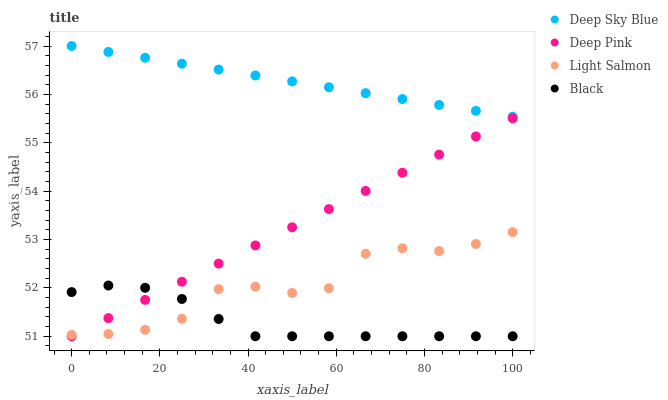Does Black have the minimum area under the curve?
Answer yes or no. Yes. Does Deep Sky Blue have the maximum area under the curve?
Answer yes or no. Yes. Does Deep Pink have the minimum area under the curve?
Answer yes or no. No. Does Deep Pink have the maximum area under the curve?
Answer yes or no. No. Is Deep Sky Blue the smoothest?
Answer yes or no. Yes. Is Light Salmon the roughest?
Answer yes or no. Yes. Is Deep Pink the smoothest?
Answer yes or no. No. Is Deep Pink the roughest?
Answer yes or no. No. Does Deep Pink have the lowest value?
Answer yes or no. Yes. Does Deep Sky Blue have the lowest value?
Answer yes or no. No. Does Deep Sky Blue have the highest value?
Answer yes or no. Yes. Does Deep Pink have the highest value?
Answer yes or no. No. Is Light Salmon less than Deep Sky Blue?
Answer yes or no. Yes. Is Deep Sky Blue greater than Light Salmon?
Answer yes or no. Yes. Does Black intersect Deep Pink?
Answer yes or no. Yes. Is Black less than Deep Pink?
Answer yes or no. No. Is Black greater than Deep Pink?
Answer yes or no. No. Does Light Salmon intersect Deep Sky Blue?
Answer yes or no. No. 